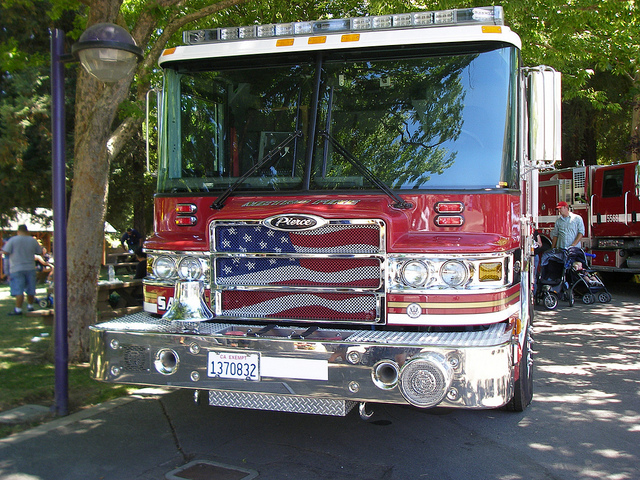Please transcribe the text in this image. Pierce 1370832 